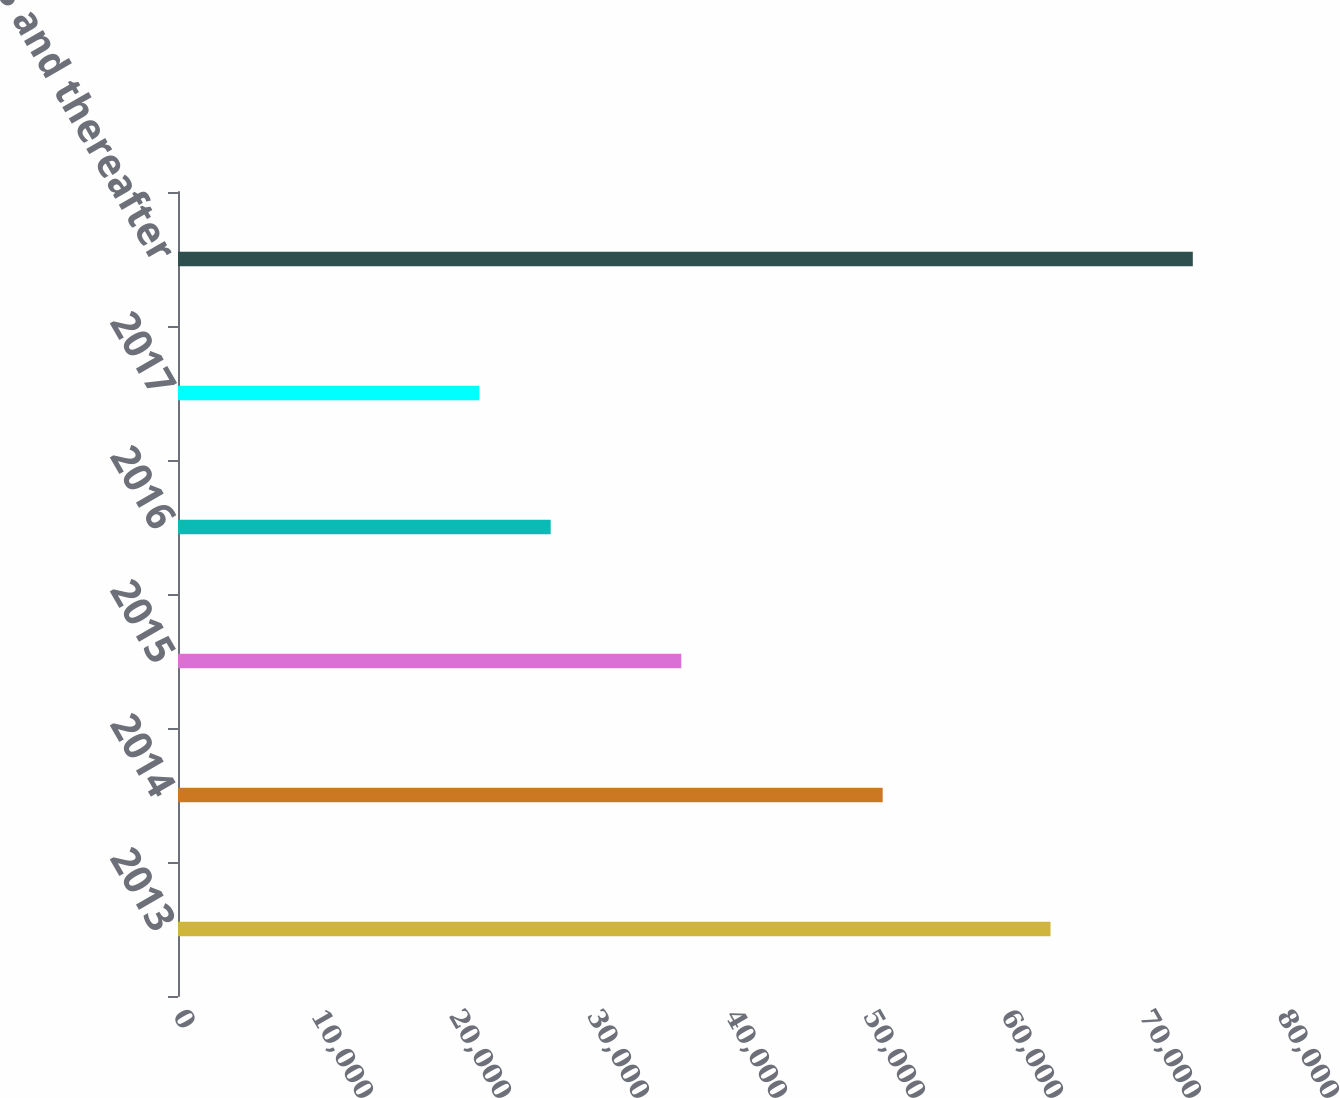Convert chart. <chart><loc_0><loc_0><loc_500><loc_500><bar_chart><fcel>2013<fcel>2014<fcel>2015<fcel>2016<fcel>2017<fcel>2018 and thereafter<nl><fcel>63228<fcel>51064<fcel>36470<fcel>27007<fcel>21837<fcel>73537<nl></chart> 